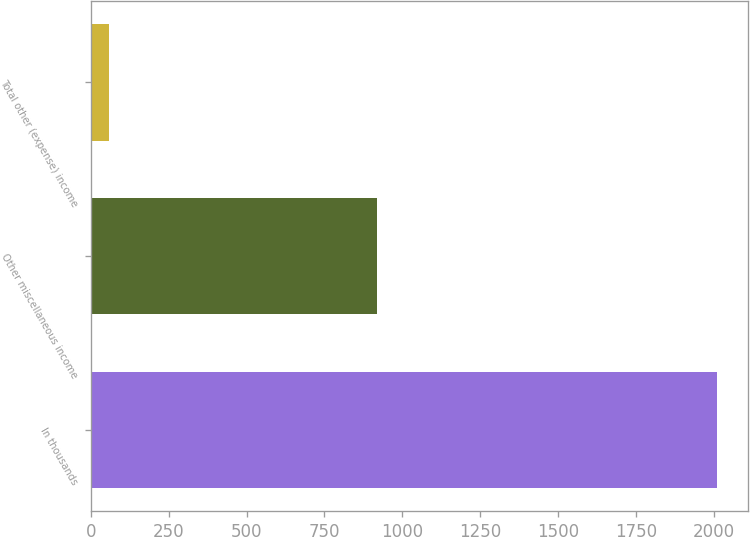Convert chart to OTSL. <chart><loc_0><loc_0><loc_500><loc_500><bar_chart><fcel>In thousands<fcel>Other miscellaneous income<fcel>Total other (expense) income<nl><fcel>2010<fcel>918<fcel>60<nl></chart> 